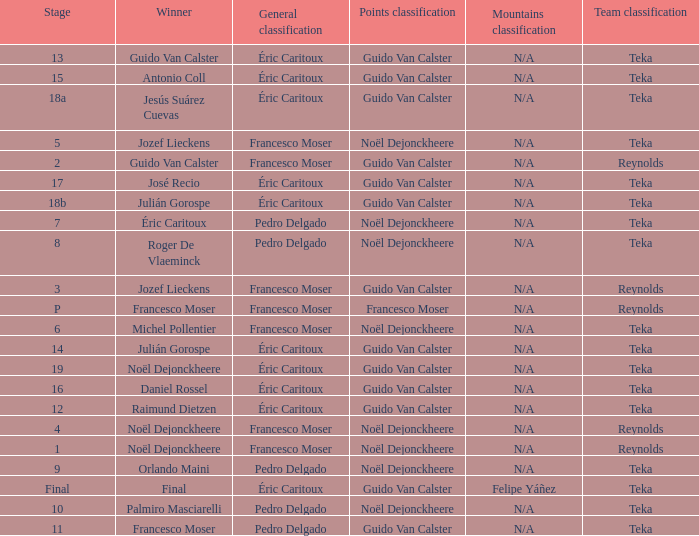Name the points classification of stage 16 Guido Van Calster. 